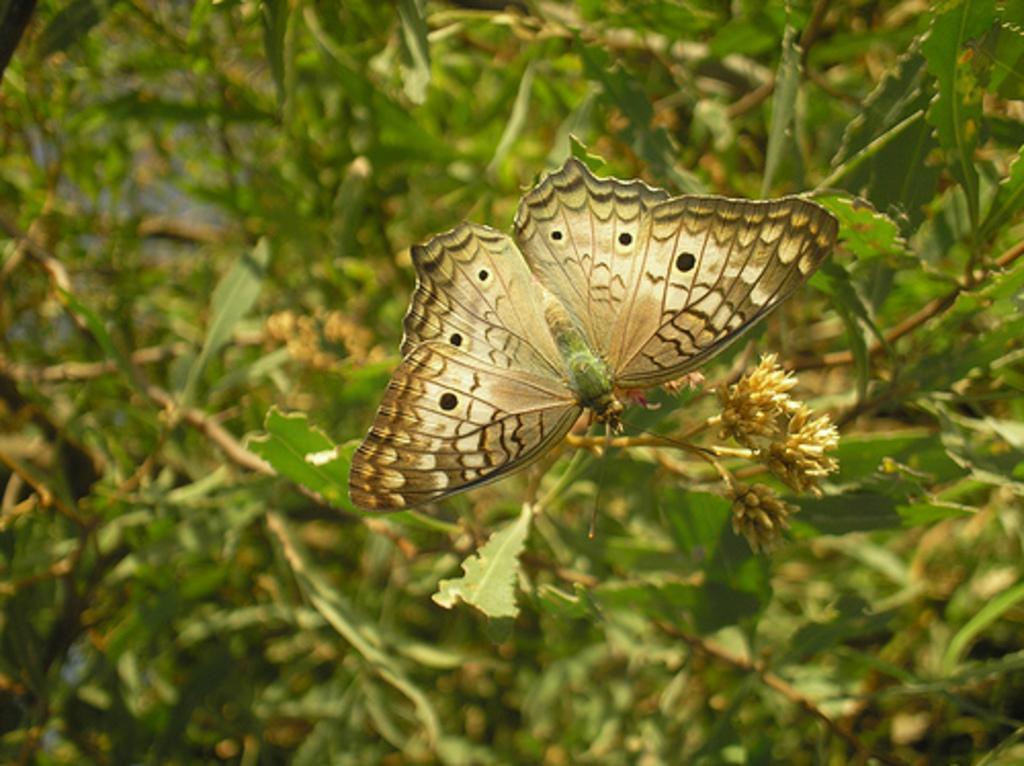Please provide a concise description of this image. In this image, we can see a butterfly and plant. In the background, there are plants and blur view. 